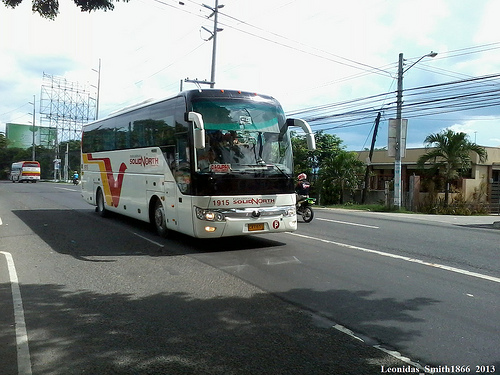Describe in detail what could be happening inside the bus in the middle of the image. Inside the bus, passengers are settled into their seats, some gazing out of the windows while others engage in conversations or use their mobile devices. The driver focuses on navigating through the traffic, keeping an eye on the road and the rear-view mirror. Perhaps a school class is on a field trip, with students chatting excitedly. The air conditioning hums softly, providing a comfortable environment for the passengers. Occasionally, the sound of a bus stop bell can be heard as someone signals to disembark. 